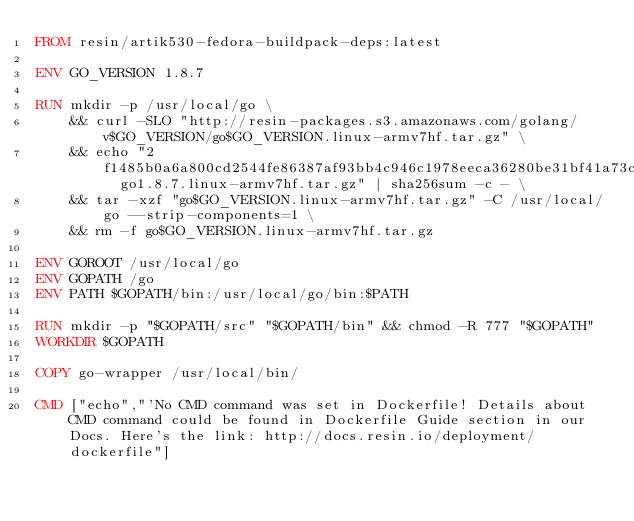Convert code to text. <code><loc_0><loc_0><loc_500><loc_500><_Dockerfile_>FROM resin/artik530-fedora-buildpack-deps:latest

ENV GO_VERSION 1.8.7

RUN mkdir -p /usr/local/go \
	&& curl -SLO "http://resin-packages.s3.amazonaws.com/golang/v$GO_VERSION/go$GO_VERSION.linux-armv7hf.tar.gz" \
	&& echo "2f1485b0a6a800cd2544fe86387af93bb4c946c1978eeca36280be31bf41a73c  go1.8.7.linux-armv7hf.tar.gz" | sha256sum -c - \
	&& tar -xzf "go$GO_VERSION.linux-armv7hf.tar.gz" -C /usr/local/go --strip-components=1 \
	&& rm -f go$GO_VERSION.linux-armv7hf.tar.gz

ENV GOROOT /usr/local/go
ENV GOPATH /go
ENV PATH $GOPATH/bin:/usr/local/go/bin:$PATH

RUN mkdir -p "$GOPATH/src" "$GOPATH/bin" && chmod -R 777 "$GOPATH"
WORKDIR $GOPATH

COPY go-wrapper /usr/local/bin/

CMD ["echo","'No CMD command was set in Dockerfile! Details about CMD command could be found in Dockerfile Guide section in our Docs. Here's the link: http://docs.resin.io/deployment/dockerfile"]
</code> 